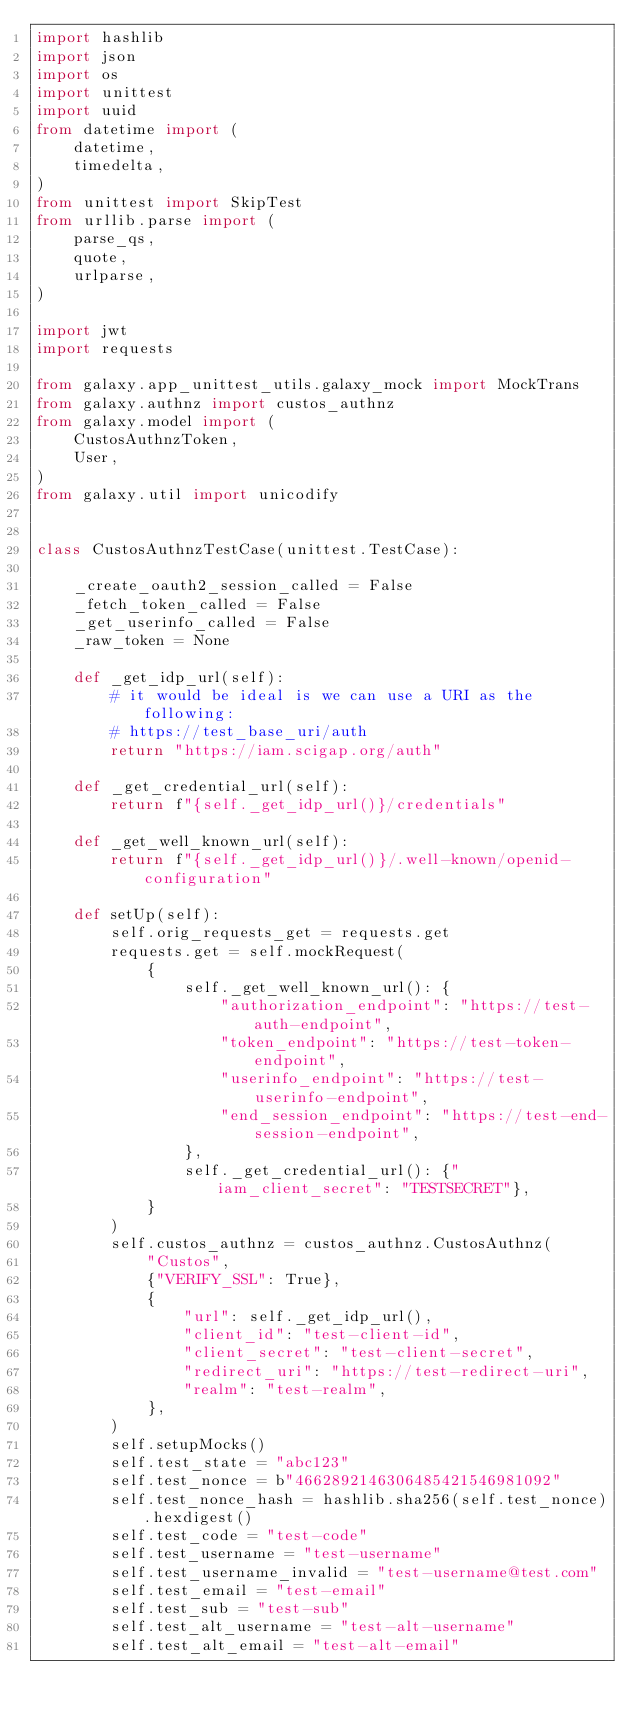Convert code to text. <code><loc_0><loc_0><loc_500><loc_500><_Python_>import hashlib
import json
import os
import unittest
import uuid
from datetime import (
    datetime,
    timedelta,
)
from unittest import SkipTest
from urllib.parse import (
    parse_qs,
    quote,
    urlparse,
)

import jwt
import requests

from galaxy.app_unittest_utils.galaxy_mock import MockTrans
from galaxy.authnz import custos_authnz
from galaxy.model import (
    CustosAuthnzToken,
    User,
)
from galaxy.util import unicodify


class CustosAuthnzTestCase(unittest.TestCase):

    _create_oauth2_session_called = False
    _fetch_token_called = False
    _get_userinfo_called = False
    _raw_token = None

    def _get_idp_url(self):
        # it would be ideal is we can use a URI as the following:
        # https://test_base_uri/auth
        return "https://iam.scigap.org/auth"

    def _get_credential_url(self):
        return f"{self._get_idp_url()}/credentials"

    def _get_well_known_url(self):
        return f"{self._get_idp_url()}/.well-known/openid-configuration"

    def setUp(self):
        self.orig_requests_get = requests.get
        requests.get = self.mockRequest(
            {
                self._get_well_known_url(): {
                    "authorization_endpoint": "https://test-auth-endpoint",
                    "token_endpoint": "https://test-token-endpoint",
                    "userinfo_endpoint": "https://test-userinfo-endpoint",
                    "end_session_endpoint": "https://test-end-session-endpoint",
                },
                self._get_credential_url(): {"iam_client_secret": "TESTSECRET"},
            }
        )
        self.custos_authnz = custos_authnz.CustosAuthnz(
            "Custos",
            {"VERIFY_SSL": True},
            {
                "url": self._get_idp_url(),
                "client_id": "test-client-id",
                "client_secret": "test-client-secret",
                "redirect_uri": "https://test-redirect-uri",
                "realm": "test-realm",
            },
        )
        self.setupMocks()
        self.test_state = "abc123"
        self.test_nonce = b"4662892146306485421546981092"
        self.test_nonce_hash = hashlib.sha256(self.test_nonce).hexdigest()
        self.test_code = "test-code"
        self.test_username = "test-username"
        self.test_username_invalid = "test-username@test.com"
        self.test_email = "test-email"
        self.test_sub = "test-sub"
        self.test_alt_username = "test-alt-username"
        self.test_alt_email = "test-alt-email"</code> 